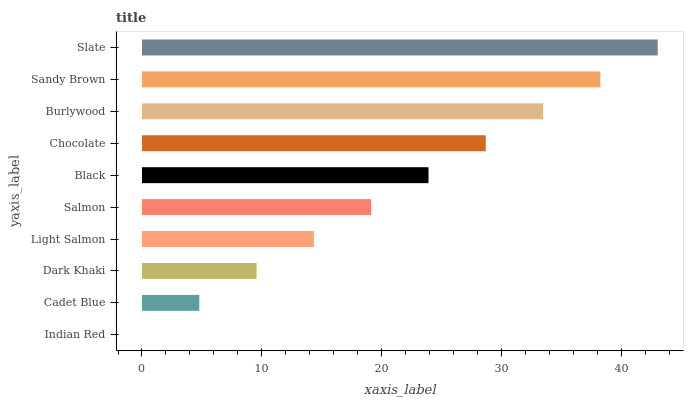Is Indian Red the minimum?
Answer yes or no. Yes. Is Slate the maximum?
Answer yes or no. Yes. Is Cadet Blue the minimum?
Answer yes or no. No. Is Cadet Blue the maximum?
Answer yes or no. No. Is Cadet Blue greater than Indian Red?
Answer yes or no. Yes. Is Indian Red less than Cadet Blue?
Answer yes or no. Yes. Is Indian Red greater than Cadet Blue?
Answer yes or no. No. Is Cadet Blue less than Indian Red?
Answer yes or no. No. Is Black the high median?
Answer yes or no. Yes. Is Salmon the low median?
Answer yes or no. Yes. Is Dark Khaki the high median?
Answer yes or no. No. Is Chocolate the low median?
Answer yes or no. No. 